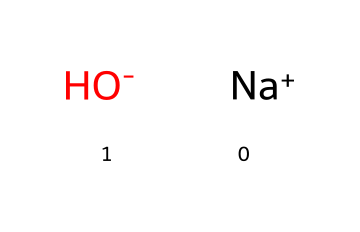What is the chemical name represented by the SMILES? The SMILES representation shows sodium (Na) bonded with a hydroxide ion (OH-); thus, the chemical name is sodium hydroxide.
Answer: sodium hydroxide How many atoms are present in the chemical structure? The structure consists of one sodium atom and one hydroxide ion that contains two atoms (oxygen and hydrogen), totaling three atoms.
Answer: three What type of bond is present in sodium hydroxide? Sodium hydroxide contains an ionic bond, as it consists of a positively charged sodium ion (Na+) and a negatively charged hydroxide ion (OH-).
Answer: ionic Does sodium hydroxide act as a strong or weak base? Sodium hydroxide is a strong base because it completely dissociates in water, increasing the concentration of hydroxide ions.
Answer: strong What is the charge of the hydroxide ion in this structure? The hydroxide ion (OH-) in the structure has a negative charge, as indicated by the minus sign in the SMILES notation.
Answer: negative Why is sodium hydroxide used in cleaning products? Sodium hydroxide is effective in cleaning products due to its ability to dissolve grease and oils, owing to its strong basic properties that can neutralize acids and saponify fats.
Answer: effective in cleaning What is the visual representation of sodium ions in the structure? The sodium ion is represented by "Na+" in the SMILES, indicating it is a positive ion; it stands alone as a separate entity without bonds, showcasing its ionic nature.
Answer: Na+ 